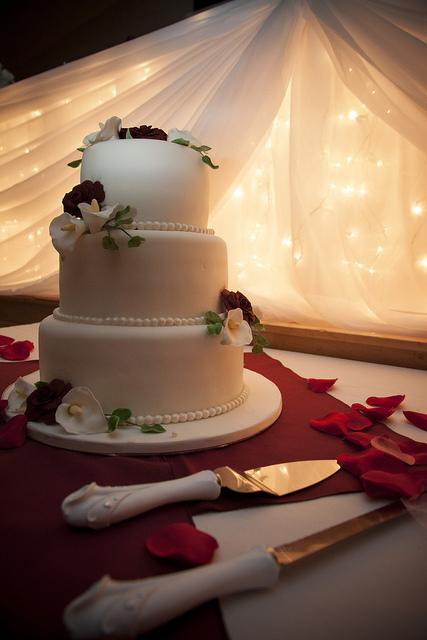Which kind of relationship is this cake typically designed for? Please explain your reasoning. romantic. The cake is white, multi-layered, and contains floral decorations. this is most consistent with the style of a wedding cake. 